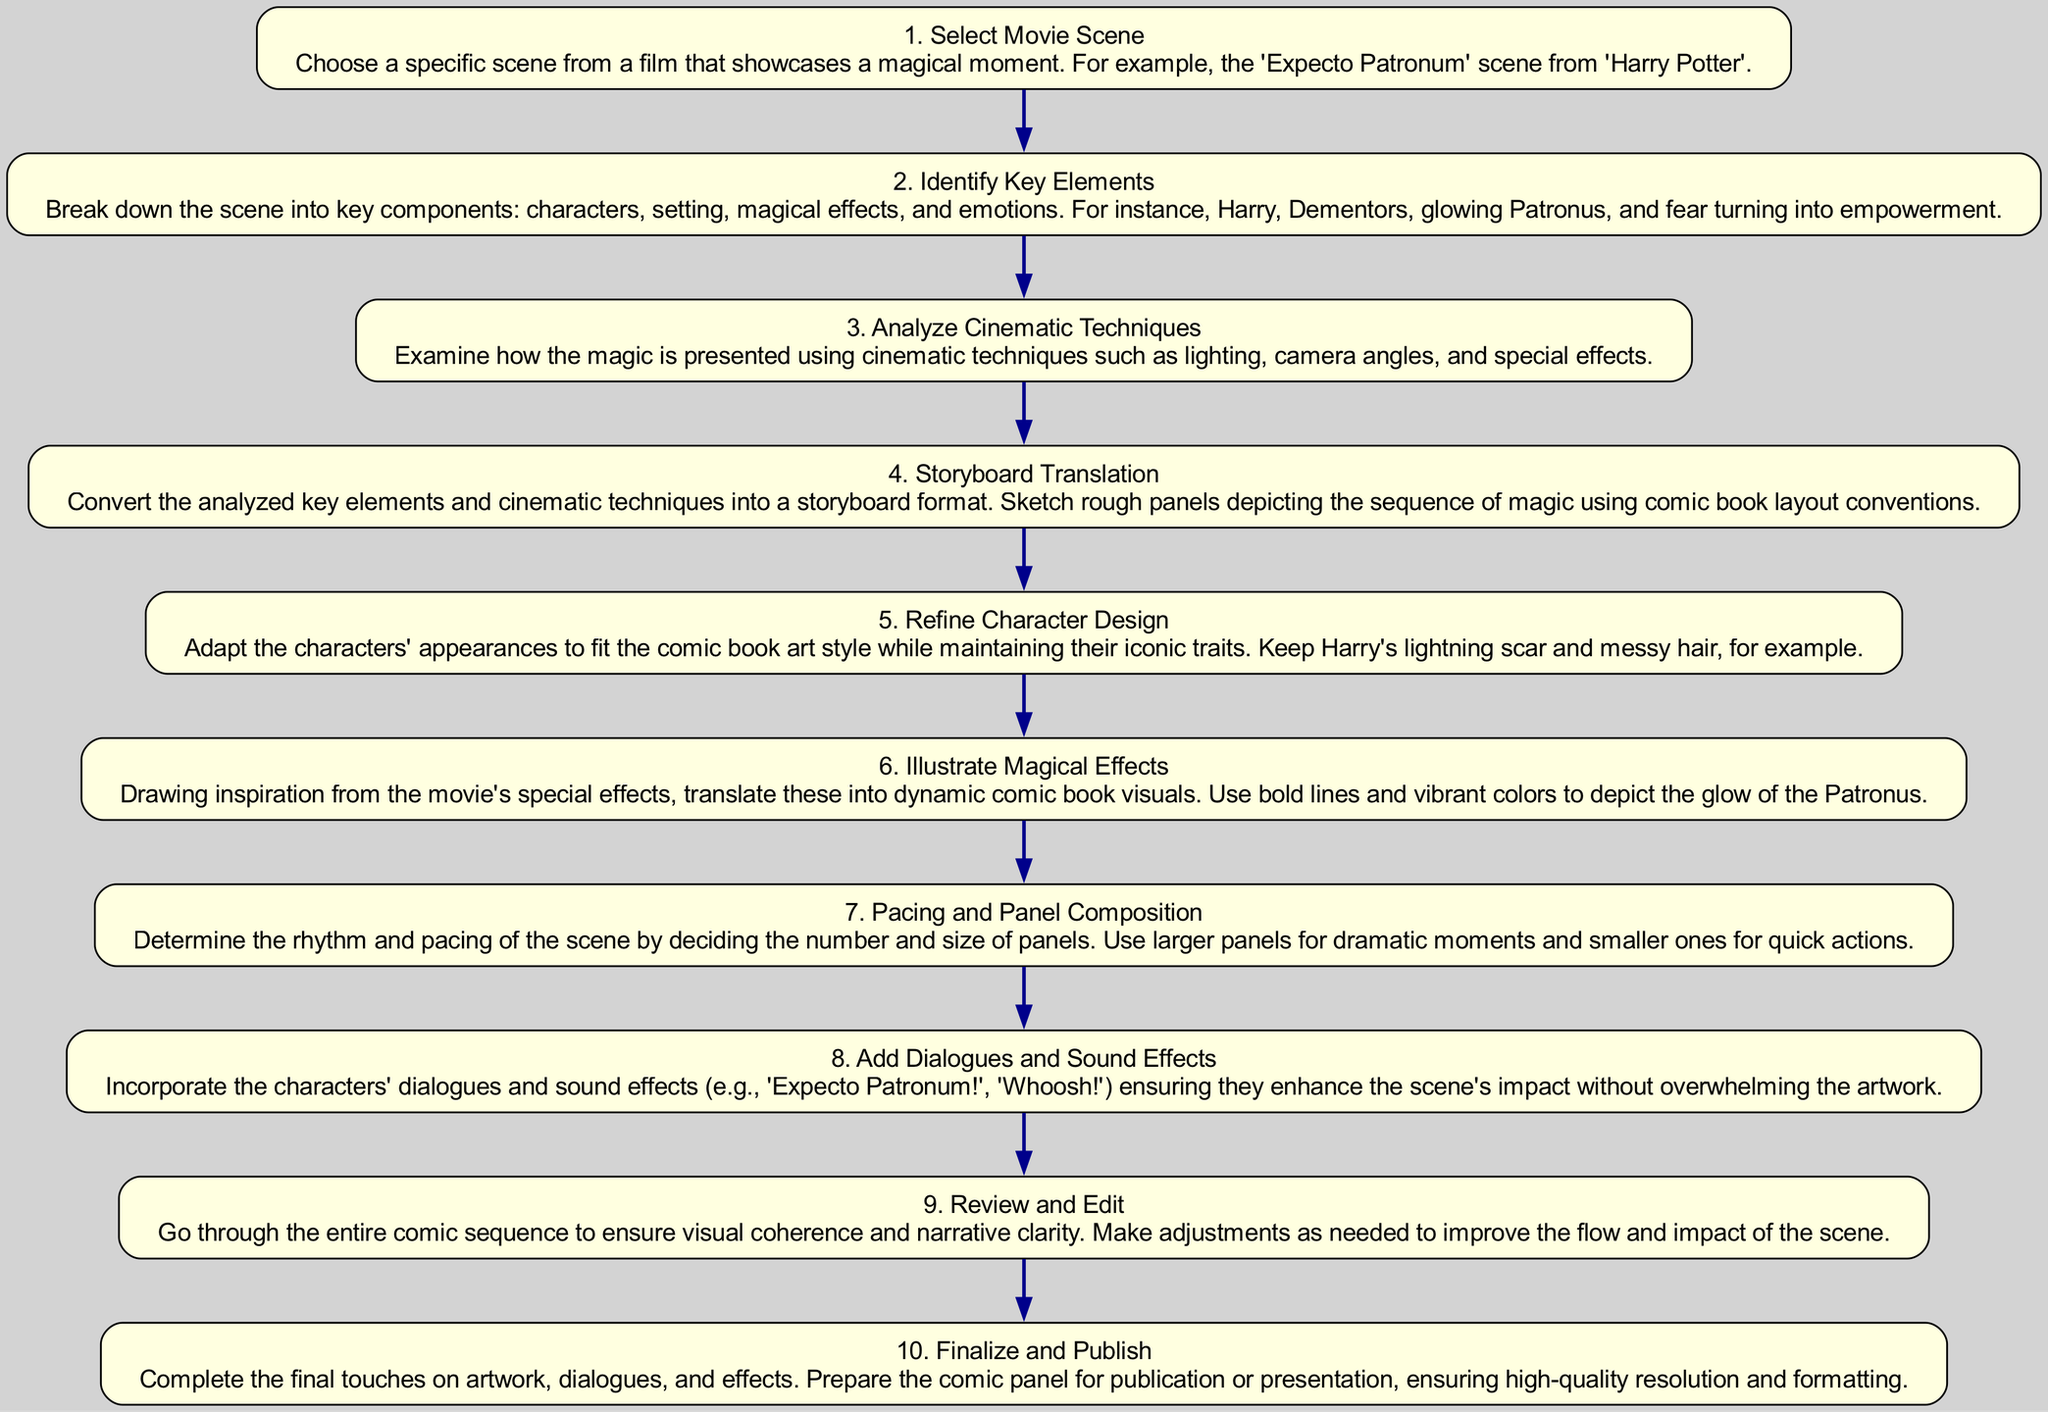What is the first step in the diagram? The first step in the flow chart is to "Select Movie Scene," which is indicated as the starting node without any incoming edges.
Answer: Select Movie Scene How many steps are there in total? By counting each node in the diagram, there are ten distinct steps laid out sequentially from start to finish.
Answer: 10 What comes after "Analyze Cinematic Techniques"? The next step after "Analyze Cinematic Techniques" is "Storyboard Translation," which follows directly from the former node in the flow.
Answer: Storyboard Translation Which step involves character design adjustments? The step titled "Refine Character Design" specifically addresses the adaptation of character appearances to fit the comic book art style.
Answer: Refine Character Design How many edges are in the diagram? The number of edges in the diagram corresponds to the number of transitions between steps, which amounts to nine edges connecting the ten nodes.
Answer: 9 What is the final step denoted in the flow chart? The last step indicated in the diagram is "Finalize and Publish," marking the conclusion of the instruction sequence.
Answer: Finalize and Publish What does the "Add Dialogues and Sound Effects" step focus on? This step emphasizes incorporating dialogues and sound effects into the comic panels to enhance the overall impact of the scenes.
Answer: Enhancing impact Which step requires examining lighting and camera angles? The step "Analyze Cinematic Techniques" involves an examination of the cinematic presentation elements, including lighting and camera angles.
Answer: Analyze Cinematic Techniques What is the purpose of the "Review and Edit" step? The purpose of "Review and Edit" is to ensure visual coherence and narrative clarity, allowing for necessary adjustments before finalization.
Answer: Ensuring coherence 